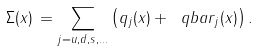<formula> <loc_0><loc_0><loc_500><loc_500>\Sigma ( x ) \, = \sum _ { j = u , d , s , \dots } \left ( q _ { j } ( x ) + \ q b a r _ { j } ( x ) \right ) .</formula> 